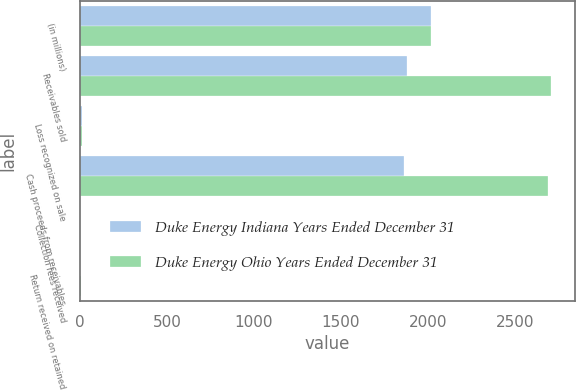Convert chart. <chart><loc_0><loc_0><loc_500><loc_500><stacked_bar_chart><ecel><fcel>(in millions)<fcel>Receivables sold<fcel>Loss recognized on sale<fcel>Cash proceeds from receivables<fcel>Collection fees received<fcel>Return received on retained<nl><fcel>Duke Energy Indiana Years Ended December 31<fcel>2017<fcel>1879<fcel>10<fcel>1865<fcel>1<fcel>3<nl><fcel>Duke Energy Ohio Years Ended December 31<fcel>2017<fcel>2711<fcel>12<fcel>2694<fcel>1<fcel>7<nl></chart> 